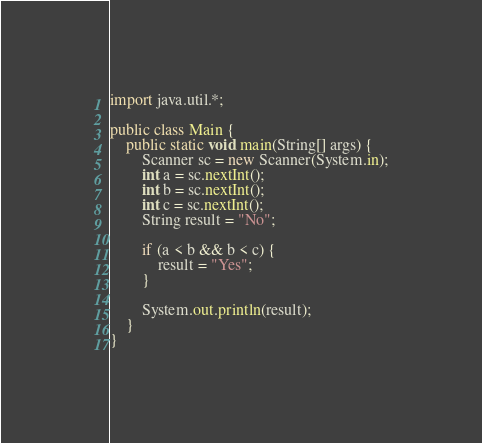<code> <loc_0><loc_0><loc_500><loc_500><_Java_>import java.util.*;

public class Main {
	public static void main(String[] args) {
		Scanner sc = new Scanner(System.in);
		int a = sc.nextInt();
		int b = sc.nextInt();
		int c = sc.nextInt();
		String result = "No";
	
		if (a < b && b < c) {
			result = "Yes";
		}

		System.out.println(result);
	}
}</code> 